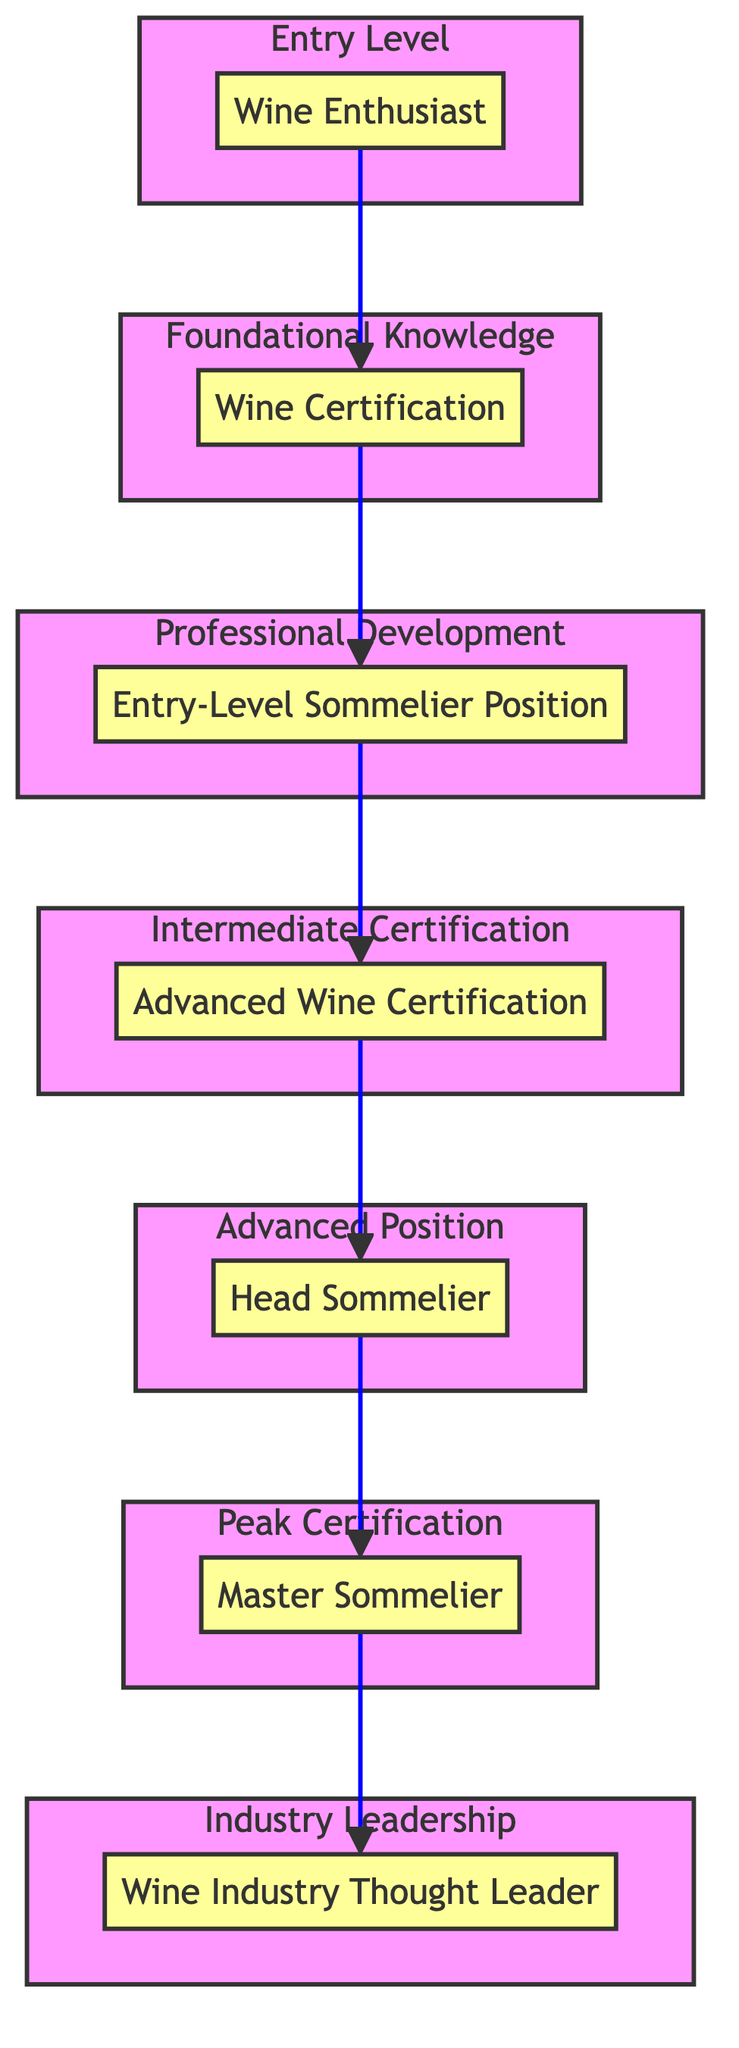What is the top level in the diagram? By looking at the diagram, the top node represents the final stage of the career path in becoming a top sommelier, which is labeled as "Wine Industry Thought Leader."
Answer: Wine Industry Thought Leader How many levels are there in the diagram? Counting all distinct stages from the bottom to the top, the diagram contains a total of six levels, which are Wine Enthusiast, Wine Certification, Entry-Level Sommelier Position, Advanced Wine Certification, Head Sommelier, Master Sommelier, and Wine Industry Thought Leader.
Answer: Six What position comes after the "Advanced Wine Certification"? Following the flow in the diagram, the position that directly follows "Advanced Wine Certification" is "Head Sommelier."
Answer: Head Sommelier Which certification is the highest in this career path? Referring to the diagram, the highest level of certification shown is "Master Sommelier" which is noted for its exceptional standard in the wine industry.
Answer: Master Sommelier What is required before obtaining a position as a "Head Sommelier"? According to the flow of the diagram, one must first achieve the "Advanced Wine Certification" to qualify for the position of "Head Sommelier."
Answer: Advanced Wine Certification Which foundational certification leads to the entry-level position? The relationship in the diagram indicates that "Wine Certification" is the foundational certification that leads to the "Entry-Level Sommelier Position."
Answer: Wine Certification Which role is suggested as a starting point in the wine career hierarchy? The diagram clearly states that the entry-level starting point in the wine career hierarchy is "Wine Enthusiast."
Answer: Wine Enthusiast What is the role of a "Wine Industry Thought Leader"? The diagram describes the role of a "Wine Industry Thought Leader" as becoming an influential figure in the industry, contributing to education and mentoring others.
Answer: Influential figure in the wine industry What type of certification precedes becoming a "Master Sommelier"? The diagram shows that one must achieve the "Head Sommelier" position before reaching the highest certification, "Master Sommelier."
Answer: Head Sommelier How does one progress from an "Entry-Level Sommelier Position" to an "Advanced Wine Certification"? The diagram illustrates that one progresses from an "Entry-Level Sommelier Position" to "Advanced Wine Certification" through hands-on experience and further study.
Answer: Hands-on experience and further study 